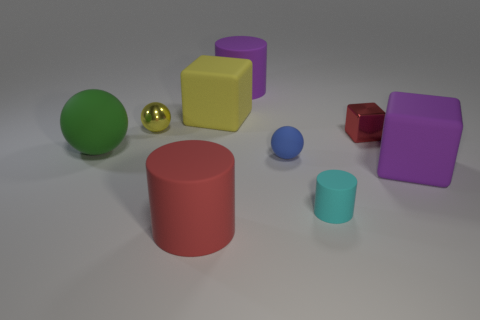The other cube that is made of the same material as the big purple block is what color?
Your answer should be very brief. Yellow. Does the tiny red thing have the same shape as the cyan rubber thing?
Your answer should be very brief. No. Is there a large cylinder that is right of the small metal object that is in front of the tiny metal object left of the large yellow cube?
Your answer should be compact. No. What number of rubber cubes are the same color as the tiny matte cylinder?
Provide a short and direct response. 0. What shape is the green object that is the same size as the purple rubber cylinder?
Your response must be concise. Sphere. Are there any rubber spheres left of the green sphere?
Keep it short and to the point. No. Is the size of the red rubber cylinder the same as the red cube?
Give a very brief answer. No. There is a yellow thing that is on the right side of the large red cylinder; what is its shape?
Provide a short and direct response. Cube. Are there any red shiny cylinders that have the same size as the green sphere?
Offer a terse response. No. There is a yellow sphere that is the same size as the blue rubber sphere; what is it made of?
Your answer should be very brief. Metal. 